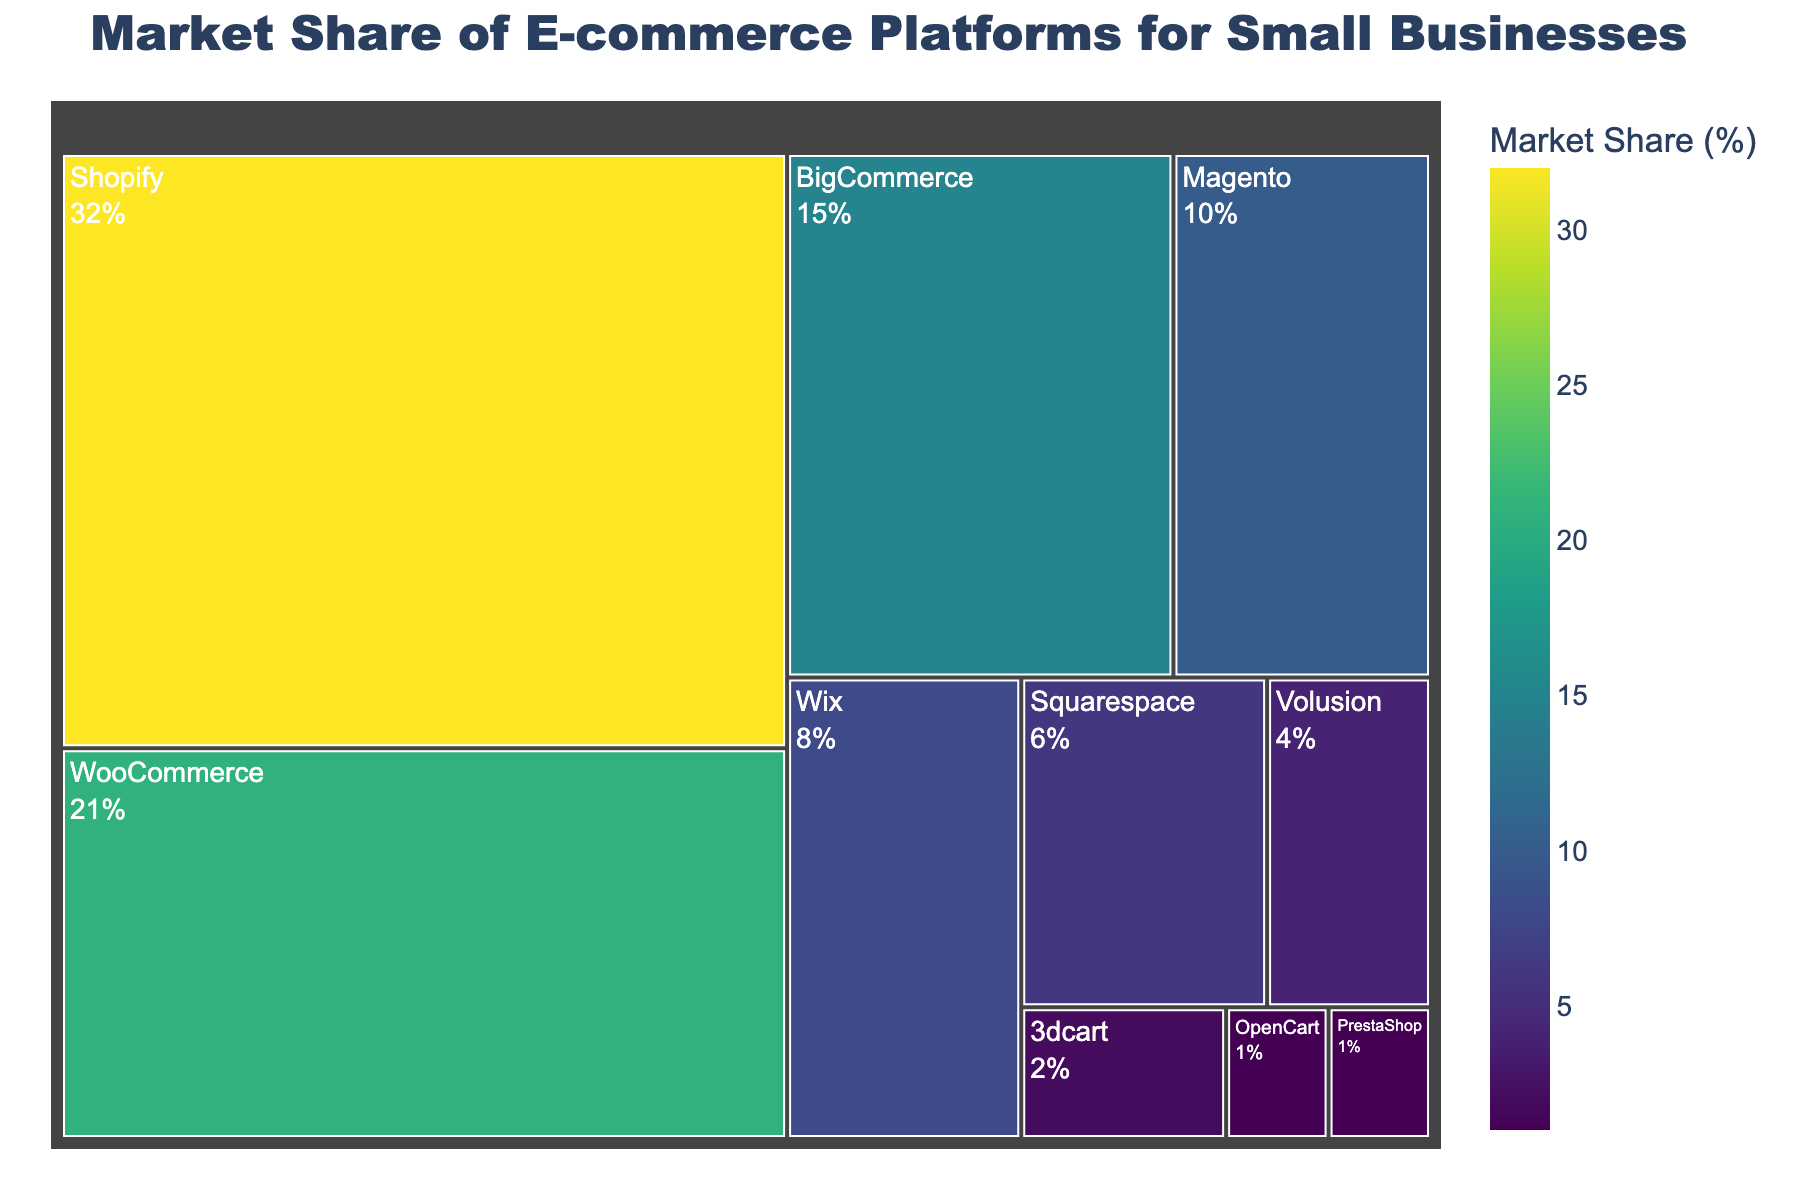Which e-commerce platform holds the largest market share? The platform with the largest segment and percentage in the treemap is the one with the greatest market share, which is indicated by Shopify having the largest section.
Answer: Shopify What is the combined market share of WooCommerce and BigCommerce? Add the market share percentages of WooCommerce (21%) and BigCommerce (15%). Therefore, 21% + 15% = 36%.
Answer: 36% Which platforms have a market share of less than 5%? Identify the platforms in the treemap with market shares indicated below 5%, namely Volusion (4%), 3dcart (2%), PrestaShop (1%), and OpenCart (1%).
Answer: Volusion, 3dcart, PrestaShop, OpenCart How much larger is Shopify's market share compared to Wix? Calculate the difference between Shopify’s market share (32%) and Wix’s market share (8%), which gives 32% - 8% = 24%.
Answer: 24% What's the total market share held by Magento, Wix, and Squarespace together? Add the market share percentages for Magento (10%), Wix (8%), and Squarespace (6%). Therefore, 10% + 8% + 6% = 24%.
Answer: 24% Which platforms have nearly equal market shares, and what are those shares? Identify platforms with approximately similar market shares in the treemap, such as PrestaShop and OpenCart, both having 1%.
Answer: PrestaShop, OpenCart What's the market share difference between BigCommerce and Squarespace? Subtract the market share of Squarespace (6%) from BigCommerce (15%), resulting in 15% - 6% = 9%.
Answer: 9% What percentage of the market do the top three platforms control? Sum the market shares of the top three platforms: Shopify (32%), WooCommerce (21%), and BigCommerce (15%), which gives 32% + 21% + 15% = 68%.
Answer: 68% How does Volusion's market share compare to 3dcart's? Compare the market share percentages: Volusion (4%) is larger than 3dcart (2%).
Answer: Volusion > 3dcart By what percentage does WooCommerce's market share surpass Magento's? Subtract Magento's market share (10%) from WooCommerce's market share (21%) to determine the difference, then express it as a percentage: 21% - 10% = 11%.
Answer: 11% 